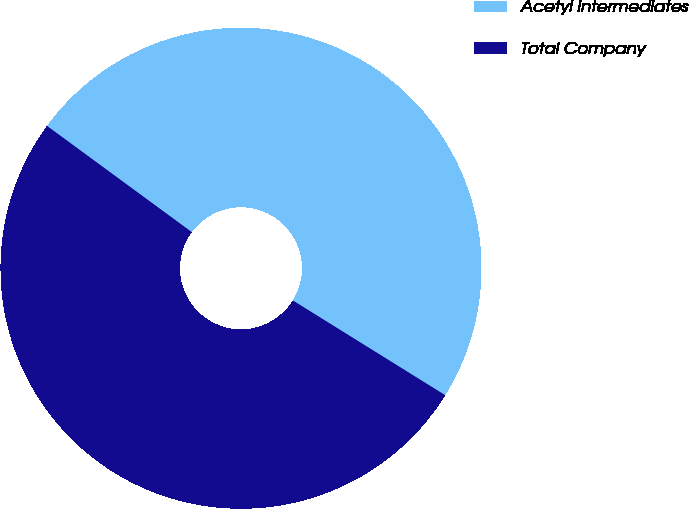Convert chart. <chart><loc_0><loc_0><loc_500><loc_500><pie_chart><fcel>Acetyl Intermediates<fcel>Total Company<nl><fcel>48.78%<fcel>51.22%<nl></chart> 